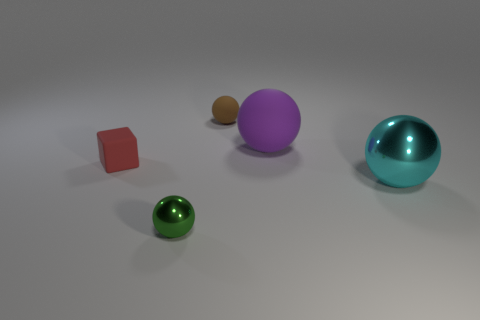Subtract all tiny green spheres. How many spheres are left? 3 Subtract 3 balls. How many balls are left? 1 Add 4 small red things. How many objects exist? 9 Subtract all cyan spheres. How many spheres are left? 3 Subtract all brown cubes. How many purple spheres are left? 1 Subtract all tiny red matte blocks. Subtract all blue shiny cylinders. How many objects are left? 4 Add 2 big purple matte balls. How many big purple matte balls are left? 3 Add 1 cyan balls. How many cyan balls exist? 2 Subtract 1 purple balls. How many objects are left? 4 Subtract all balls. How many objects are left? 1 